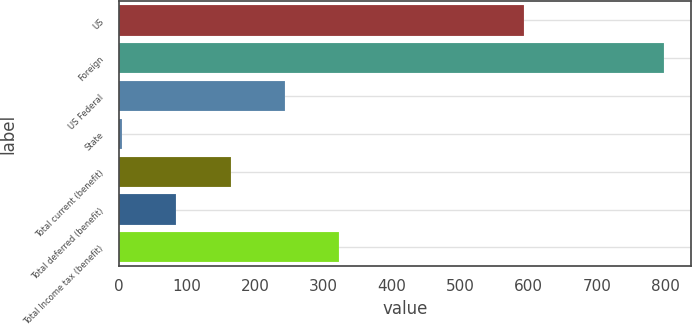<chart> <loc_0><loc_0><loc_500><loc_500><bar_chart><fcel>US<fcel>Foreign<fcel>US Federal<fcel>State<fcel>Total current (benefit)<fcel>Total deferred (benefit)<fcel>Total Income tax (benefit)<nl><fcel>593.4<fcel>797.9<fcel>243.08<fcel>5.3<fcel>163.82<fcel>84.56<fcel>322.34<nl></chart> 